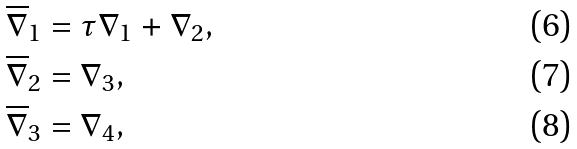Convert formula to latex. <formula><loc_0><loc_0><loc_500><loc_500>\overline { \nabla } _ { 1 } & = \tau \nabla _ { 1 } + \nabla _ { 2 } , \\ \overline { \nabla } _ { 2 } & = \nabla _ { 3 } , \\ \overline { \nabla } _ { 3 } & = \nabla _ { 4 } ,</formula> 